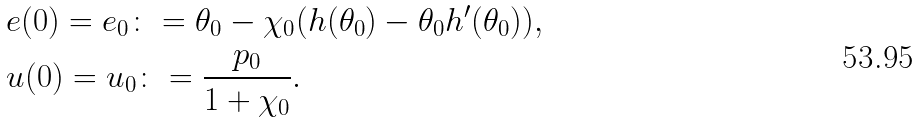<formula> <loc_0><loc_0><loc_500><loc_500>& e ( 0 ) = e _ { 0 } \colon = \theta _ { 0 } - \chi _ { 0 } ( h ( \theta _ { 0 } ) - \theta _ { 0 } h ^ { \prime } ( \theta _ { 0 } ) ) , \\ & u ( 0 ) = u _ { 0 } \colon = \frac { p _ { 0 } } { 1 + \chi _ { 0 } } .</formula> 